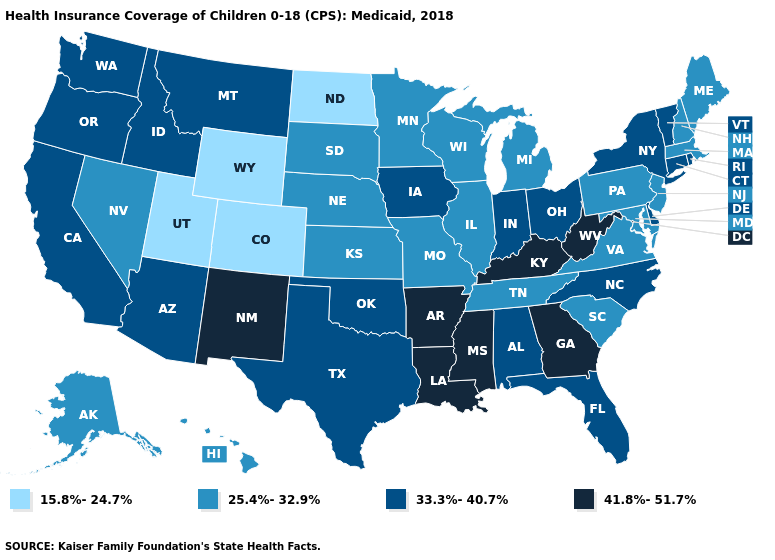What is the lowest value in the USA?
Short answer required. 15.8%-24.7%. What is the highest value in the West ?
Write a very short answer. 41.8%-51.7%. What is the highest value in the USA?
Concise answer only. 41.8%-51.7%. Does New York have a higher value than Minnesota?
Give a very brief answer. Yes. What is the highest value in the USA?
Keep it brief. 41.8%-51.7%. Does Kansas have the lowest value in the USA?
Write a very short answer. No. Name the states that have a value in the range 33.3%-40.7%?
Short answer required. Alabama, Arizona, California, Connecticut, Delaware, Florida, Idaho, Indiana, Iowa, Montana, New York, North Carolina, Ohio, Oklahoma, Oregon, Rhode Island, Texas, Vermont, Washington. Which states have the lowest value in the Northeast?
Be succinct. Maine, Massachusetts, New Hampshire, New Jersey, Pennsylvania. Name the states that have a value in the range 15.8%-24.7%?
Concise answer only. Colorado, North Dakota, Utah, Wyoming. Does Michigan have a lower value than Nevada?
Answer briefly. No. Which states have the highest value in the USA?
Short answer required. Arkansas, Georgia, Kentucky, Louisiana, Mississippi, New Mexico, West Virginia. What is the lowest value in states that border Mississippi?
Concise answer only. 25.4%-32.9%. Among the states that border Idaho , which have the lowest value?
Give a very brief answer. Utah, Wyoming. Does Wyoming have the lowest value in the USA?
Short answer required. Yes. What is the value of Maine?
Concise answer only. 25.4%-32.9%. 